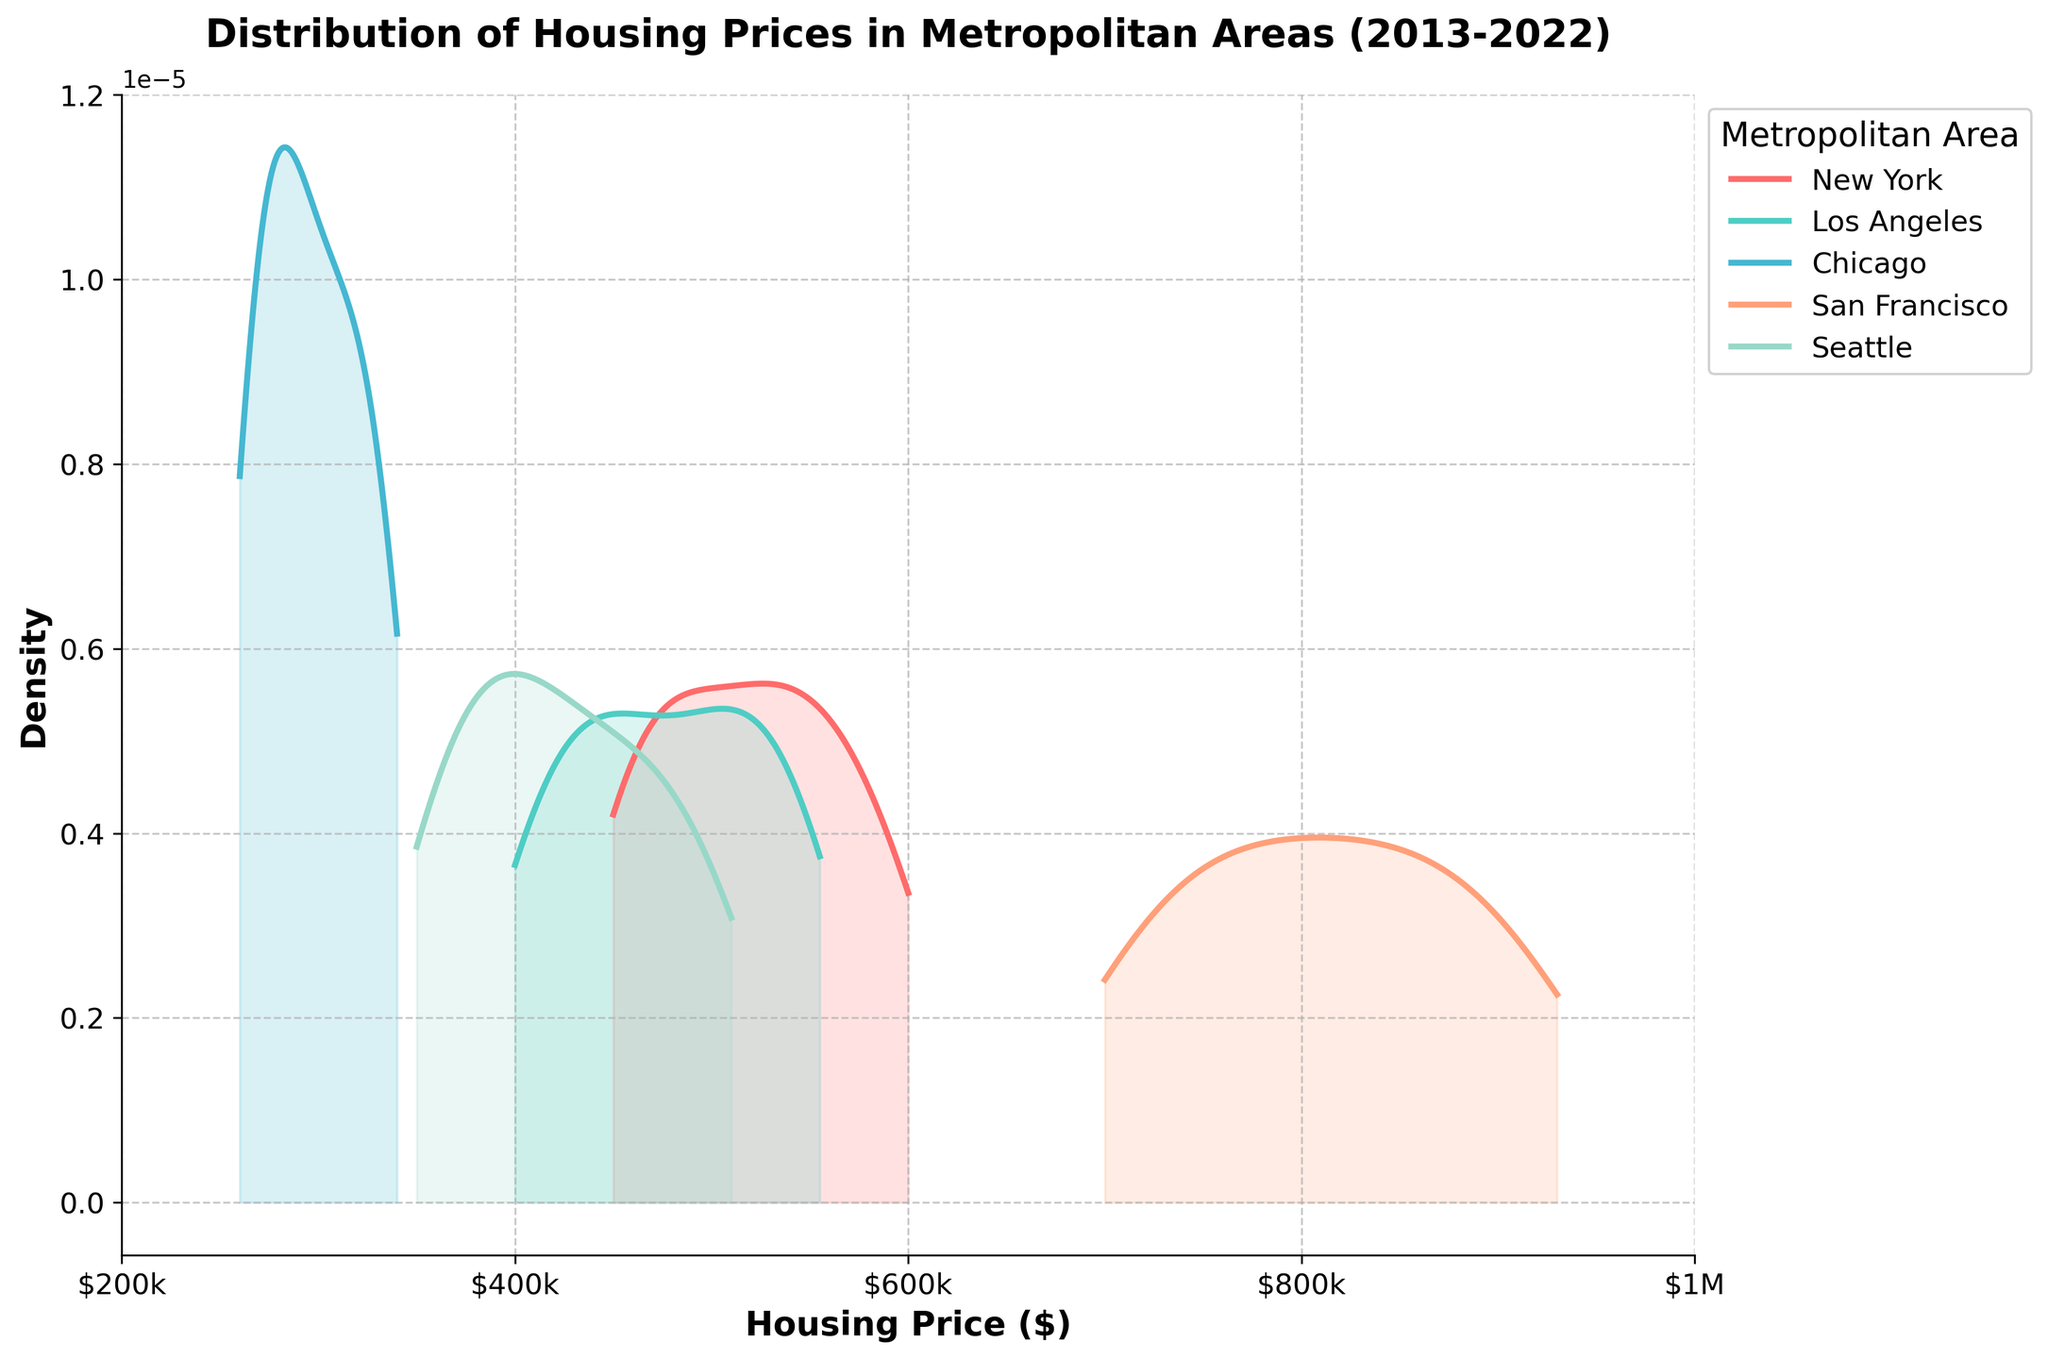what is the title of the plot? The title of the plot is shown at the top, stating, "Distribution of Housing Prices in Metropolitan Areas (2013-2022)"
Answer: Distribution of Housing Prices in Metropolitan Areas (2013-2022) What is the x-axis label? The x-axis label appears at the bottom of the plot and is "Housing Price ($)"
Answer: Housing Price ($) Which metropolitan area's housing prices are depicted using a color that contains red? The legend on the right associates each metropolitan area with a color. The color that contains red is used for "New York"
Answer: New York How many metropolitan areas are shown in the plot? The legend on the right lists all metropolitan areas depicted in the plot. There are five metropolitan areas listed there: New York, Los Angeles, Chicago, San Francisco, and Seattle
Answer: 5 What is the y-axis label? The y-axis label, shown on the left side of the plot, is "Density"
Answer: Density Which metropolitan area had the highest peak density in housing prices? The highest peak density is represented by the highest point of the density curve. The curve for San Francisco has the highest peak density among all metropolitan areas
Answer: San Francisco Which metropolitan area has the highest housing prices range? The range of housing prices is shown on the x-axis, and San Francisco's data starts from the highest minimum value and ends at the highest maximum value among all areas
Answer: San Francisco Whose housing price distribution curve is mostly concentrated around the $300k-$400k range? The curve which peaks around the $300k-$400k range indicates that the housing prices are mostly distributed in this range. The curve for Chicago shows this concentration
Answer: Chicago Compare the spread of housing prices for Seattle and New York. Which one has a wider spread? The spread refers to the range of the x-axis values where the density is non-zero. Seattle's distribution spans from around $350k to $510k, whereas New York's spans from around $450k to $600k. New York has a broader coverage on the x-axis
Answer: New York Between Los Angeles and Chicago, which metropolitan area's housing price distribution is more skewed to the higher prices? The skewness is indicated by the elongation of the density curve toward higher prices. Los Angeles' curve peaks lower and stretches more towards higher prices compared to Chicago
Answer: Los Angeles 